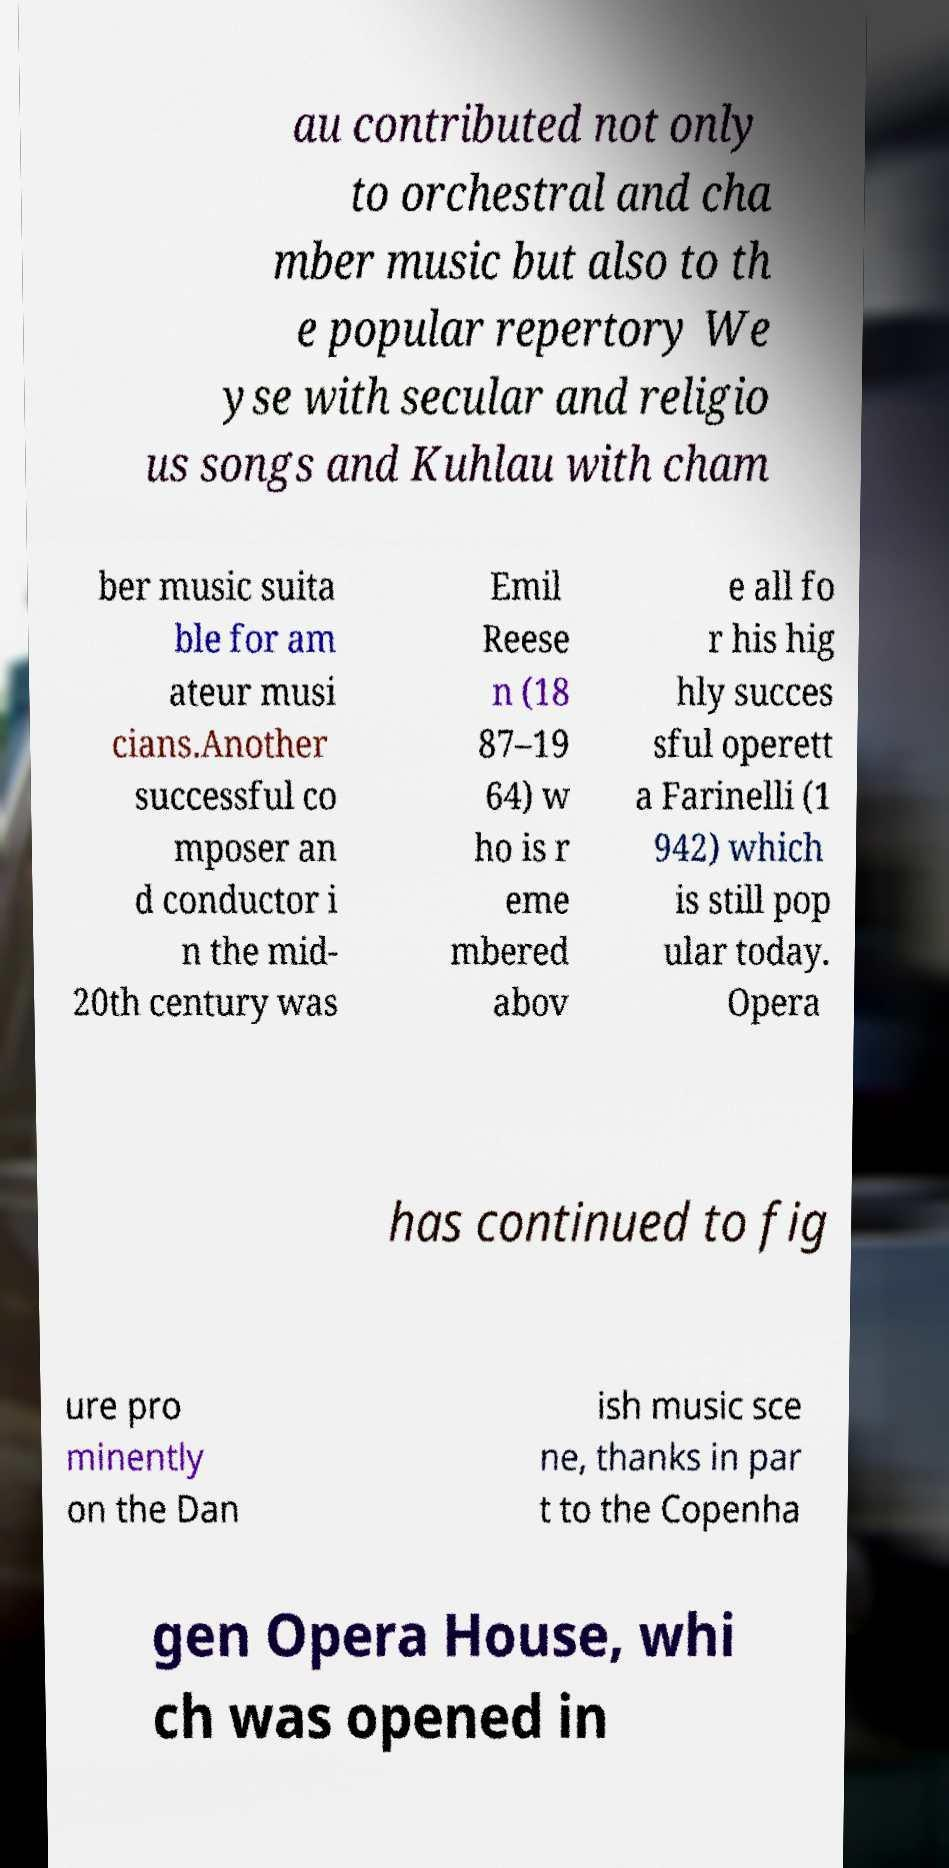Can you read and provide the text displayed in the image?This photo seems to have some interesting text. Can you extract and type it out for me? au contributed not only to orchestral and cha mber music but also to th e popular repertory We yse with secular and religio us songs and Kuhlau with cham ber music suita ble for am ateur musi cians.Another successful co mposer an d conductor i n the mid- 20th century was Emil Reese n (18 87–19 64) w ho is r eme mbered abov e all fo r his hig hly succes sful operett a Farinelli (1 942) which is still pop ular today. Opera has continued to fig ure pro minently on the Dan ish music sce ne, thanks in par t to the Copenha gen Opera House, whi ch was opened in 